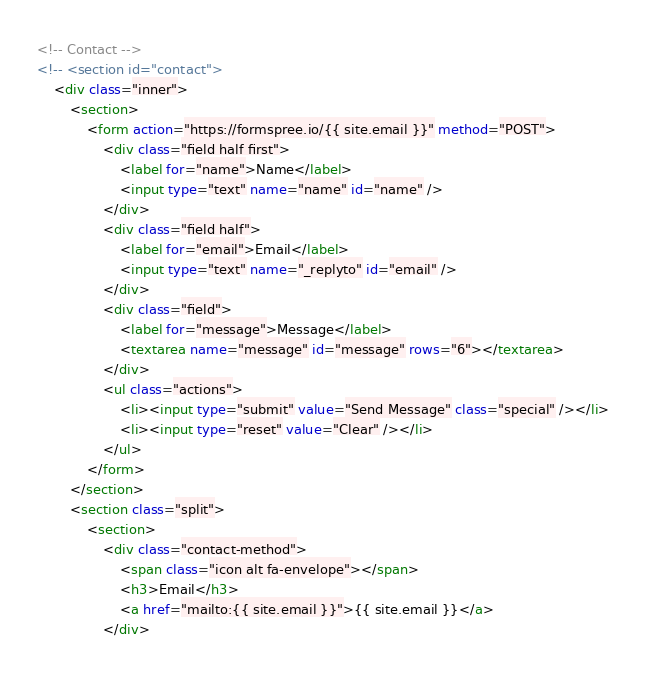<code> <loc_0><loc_0><loc_500><loc_500><_HTML_><!-- Contact -->
<!-- <section id="contact">
	<div class="inner">
		<section>
			<form action="https://formspree.io/{{ site.email }}" method="POST">
				<div class="field half first">
					<label for="name">Name</label>
					<input type="text" name="name" id="name" />
				</div>
				<div class="field half">
					<label for="email">Email</label>
					<input type="text" name="_replyto" id="email" />
				</div>
				<div class="field">
					<label for="message">Message</label>
					<textarea name="message" id="message" rows="6"></textarea>
				</div>
				<ul class="actions">
					<li><input type="submit" value="Send Message" class="special" /></li>
					<li><input type="reset" value="Clear" /></li>
				</ul>
			</form>
		</section>
		<section class="split">
			<section>
				<div class="contact-method">
					<span class="icon alt fa-envelope"></span>
					<h3>Email</h3>
					<a href="mailto:{{ site.email }}">{{ site.email }}</a>
				</div></code> 